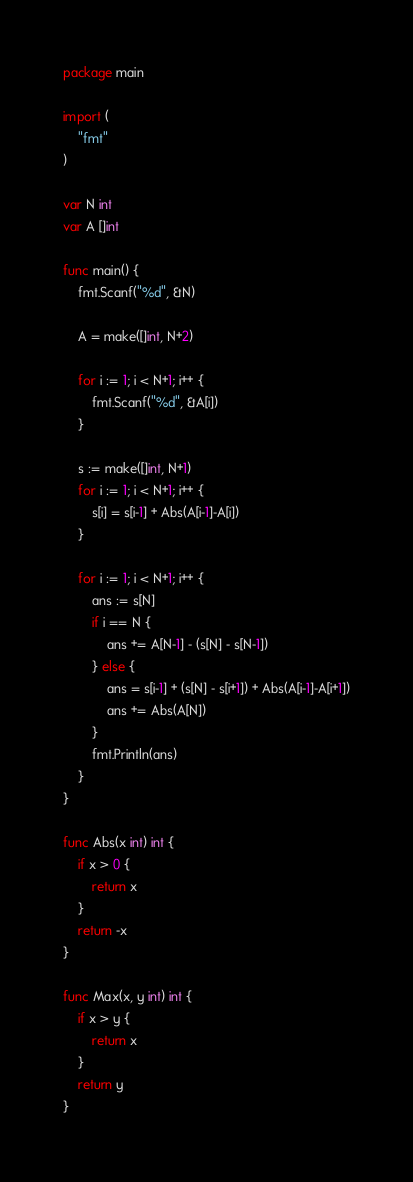Convert code to text. <code><loc_0><loc_0><loc_500><loc_500><_Go_>package main

import (
	"fmt"
)

var N int
var A []int

func main() {
	fmt.Scanf("%d", &N)

	A = make([]int, N+2)

	for i := 1; i < N+1; i++ {
		fmt.Scanf("%d", &A[i])
	}

	s := make([]int, N+1)
	for i := 1; i < N+1; i++ {
		s[i] = s[i-1] + Abs(A[i-1]-A[i])
	}

	for i := 1; i < N+1; i++ {
		ans := s[N]
		if i == N {
			ans += A[N-1] - (s[N] - s[N-1])
		} else {
			ans = s[i-1] + (s[N] - s[i+1]) + Abs(A[i-1]-A[i+1])
			ans += Abs(A[N])
		}
		fmt.Println(ans)
	}
}

func Abs(x int) int {
	if x > 0 {
		return x
	}
	return -x
}

func Max(x, y int) int {
	if x > y {
		return x
	}
	return y
}
</code> 